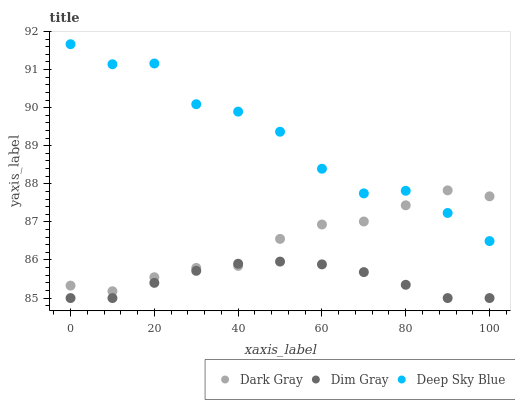Does Dim Gray have the minimum area under the curve?
Answer yes or no. Yes. Does Deep Sky Blue have the maximum area under the curve?
Answer yes or no. Yes. Does Deep Sky Blue have the minimum area under the curve?
Answer yes or no. No. Does Dim Gray have the maximum area under the curve?
Answer yes or no. No. Is Dim Gray the smoothest?
Answer yes or no. Yes. Is Deep Sky Blue the roughest?
Answer yes or no. Yes. Is Deep Sky Blue the smoothest?
Answer yes or no. No. Is Dim Gray the roughest?
Answer yes or no. No. Does Dim Gray have the lowest value?
Answer yes or no. Yes. Does Deep Sky Blue have the lowest value?
Answer yes or no. No. Does Deep Sky Blue have the highest value?
Answer yes or no. Yes. Does Dim Gray have the highest value?
Answer yes or no. No. Is Dim Gray less than Deep Sky Blue?
Answer yes or no. Yes. Is Deep Sky Blue greater than Dim Gray?
Answer yes or no. Yes. Does Dark Gray intersect Deep Sky Blue?
Answer yes or no. Yes. Is Dark Gray less than Deep Sky Blue?
Answer yes or no. No. Is Dark Gray greater than Deep Sky Blue?
Answer yes or no. No. Does Dim Gray intersect Deep Sky Blue?
Answer yes or no. No. 